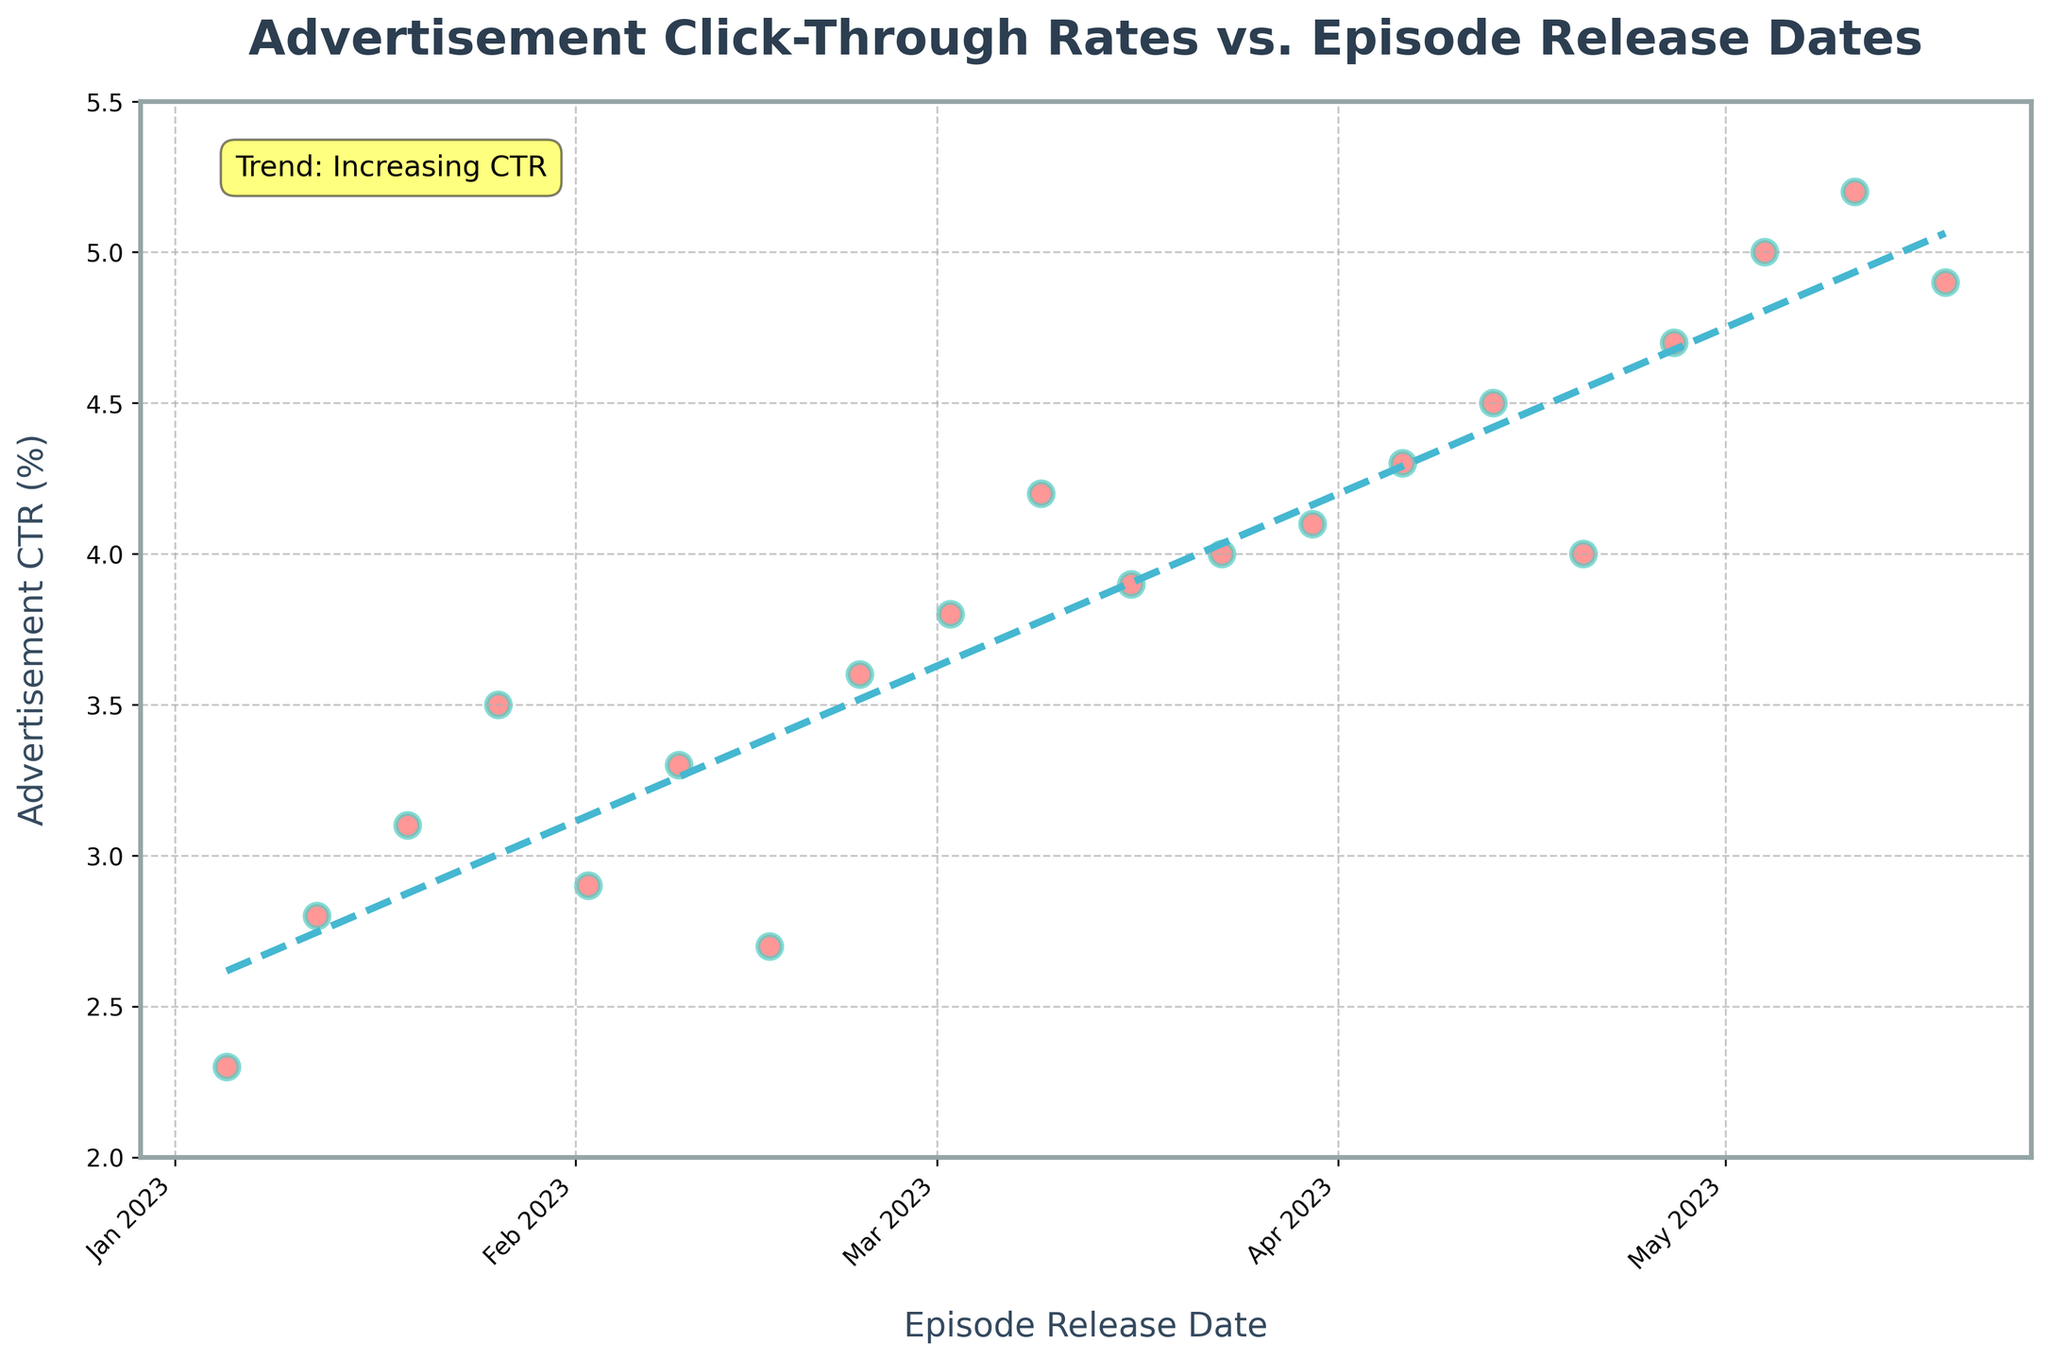What is the title of the plot? The title is located at the top center of the plot and is displayed prominently. It reads "Advertisement Click-Through Rates vs. Episode Release Dates".
Answer: Advertisement Click-Through Rates vs. Episode Release Dates What color are the data points in the scatter plot? The data points in the scatter plot are displayed in a noticeable color. They are red with a slight transparency and have a teal edge.
Answer: Red with teal edges How many data points are plotted in the scatter plot? By counting the number of red data points plotted across the horizontal axis (Episode Release Dates), you can determine the total number of data points. There are 20 points plotted from January 05, 2023, to May 18, 2023.
Answer: 20 What is the CTR value for the episode released on February 23, 2023? Locate the data point corresponding to February 23, 2023, on the horizontal axis, then check its vertical position. It aligns with the CTR value of 3.6%.
Answer: 3.6% Which episode release date corresponds to the lowest advertisement CTR? By looking at the data points on the scatter plot, the lowest vertical position corresponds to the smallest CTR value. This is shown for the episode released on January 05, 2023, with a CTR of 2.3%.
Answer: January 05, 2023 What is the general trend of the advertisement CTR over time? Observing the trend line (dashed line) in the plot, it slopes upwards from left to right, indicating that the advertisement CTR increases over time. This is also supported by the text annotation indicating an "Increasing CTR" trend.
Answer: Increasing By how much did the average CTR increase from January (2023) to May (2023)? Calculate the average CTR for January and May by averaging their respective CTR values: January: (2.3 + 2.8 + 3.1 + 3.5)/4 = 2.925. May: (4.9 + 5.2)/2 = 5.05. Then find the difference: 5.05 - 2.925 = 2.125.
Answer: 2.125% What is the difference in advertisement CTR between the episode released on April 27, 2023, and the episode released on January 26, 2023? Compare the CTR values for these dates: April 27, 2023 (4.7%) and January 26, 2023 (3.5%). Subtract the January value from the April value: 4.7 - 3.5 = 1.2.
Answer: 1.2% Which month shows the highest advertisement CTR based on the scatter plot data? Identify the month with the data point at the highest position on the vertical axis. May 2023 has the highest CTR values, going up to 5.2%.
Answer: May 2023 What is the trend line equation for the plot? The trend line equation was obtained through polynomial fitting in the given code. While the exact coefficients aren't provided, the equation visually represents the increasing trend in the plot, indicating a positive slope.
Answer: Increasing with a positive slope 